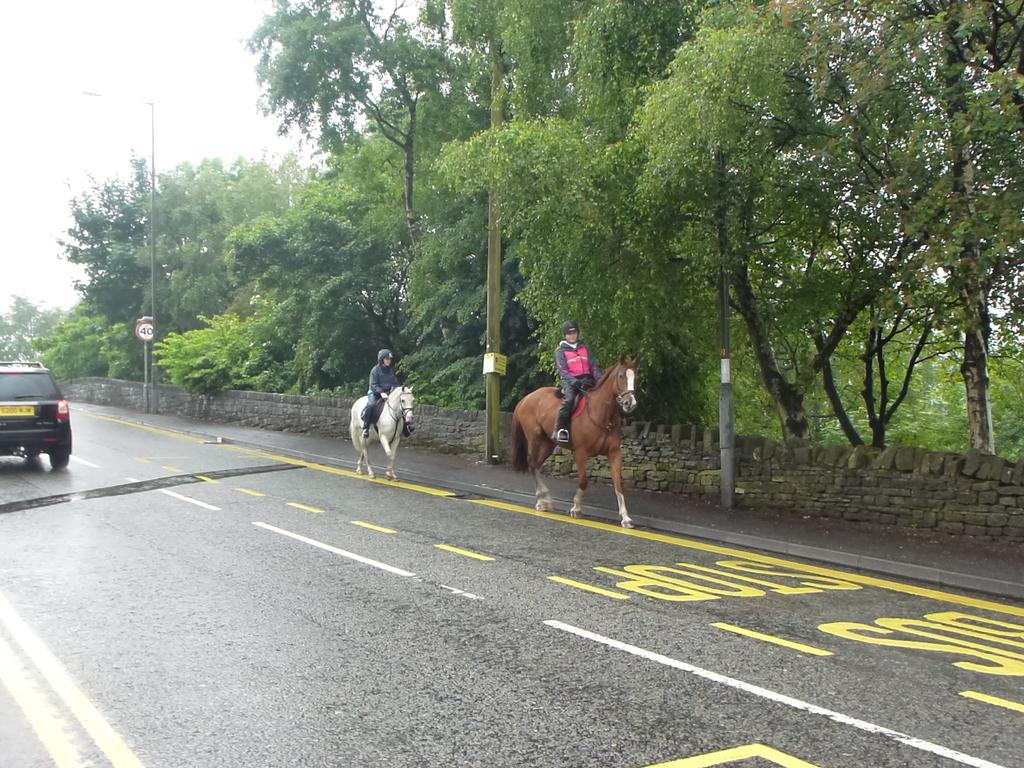How many horses are in the image? There are two horses in the image. What are the horses doing in the image? Two persons are sitting on the horses. What else can be seen on the road in the image? There is a car on the road in the image. What is visible in the background of the image? Trees are visible in the background of the image. Can you see any goldfish swimming in the image? There are no goldfish present in the image; it features horses, a car, and trees. What type of badge is being worn by the jellyfish in the image? There are no jellyfish or badges present in the image. 